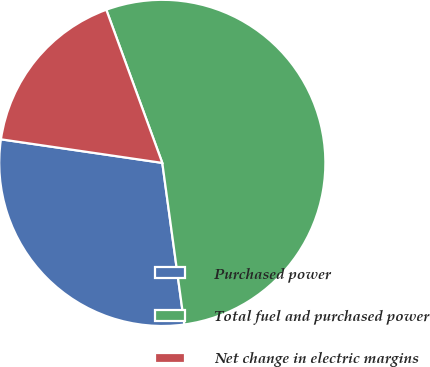Convert chart to OTSL. <chart><loc_0><loc_0><loc_500><loc_500><pie_chart><fcel>Purchased power<fcel>Total fuel and purchased power<fcel>Net change in electric margins<nl><fcel>29.47%<fcel>53.42%<fcel>17.11%<nl></chart> 